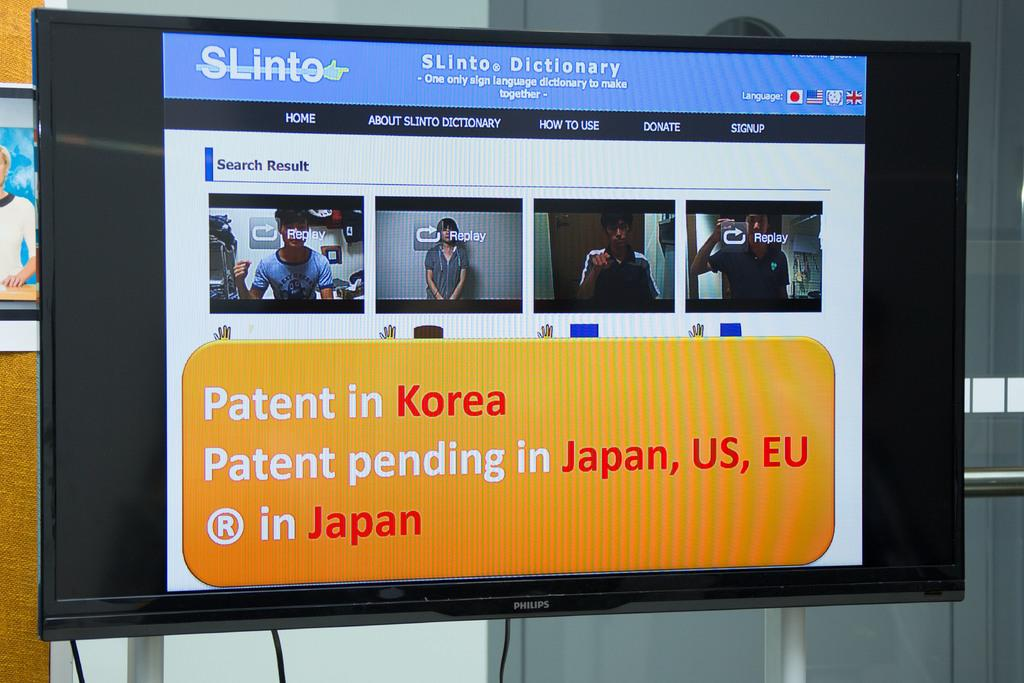<image>
Give a short and clear explanation of the subsequent image. Monitor showing the patent pending with screens of people. 